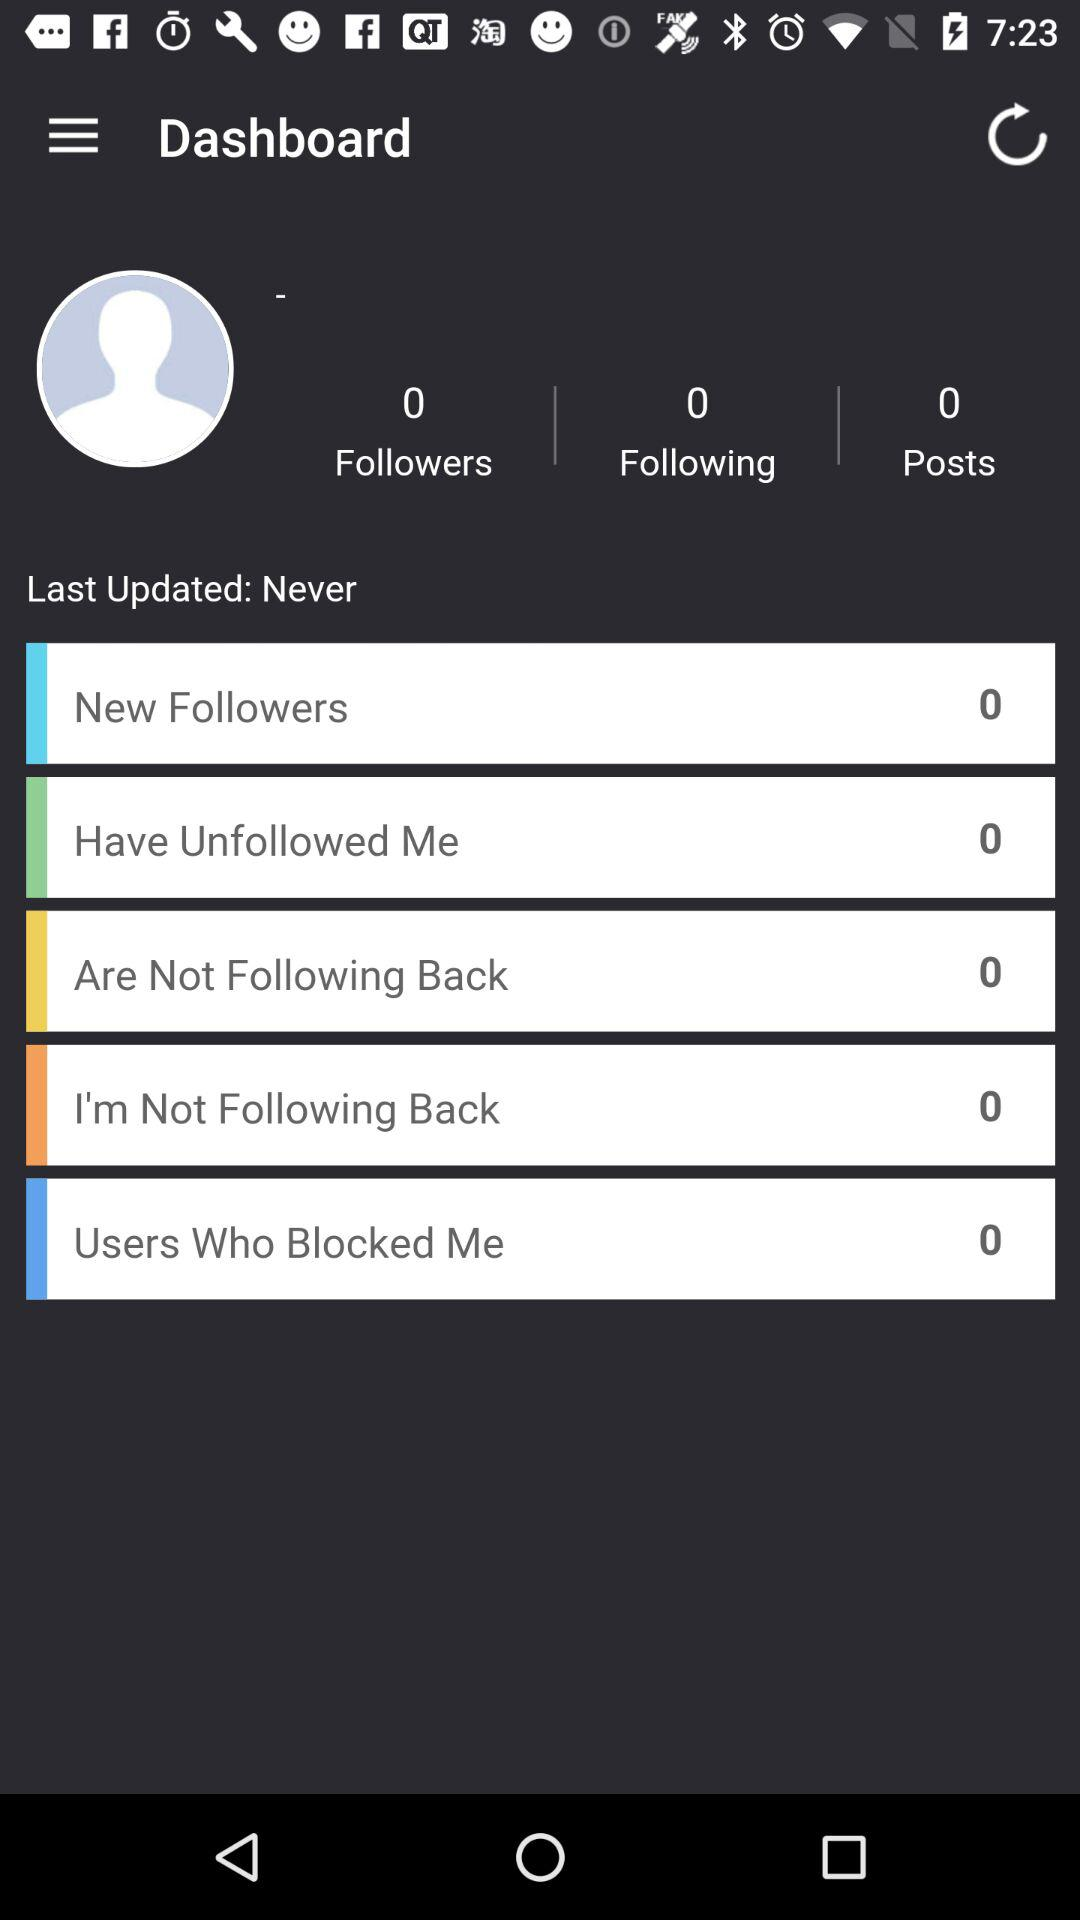When was the last update done? The last update was done "Never". 